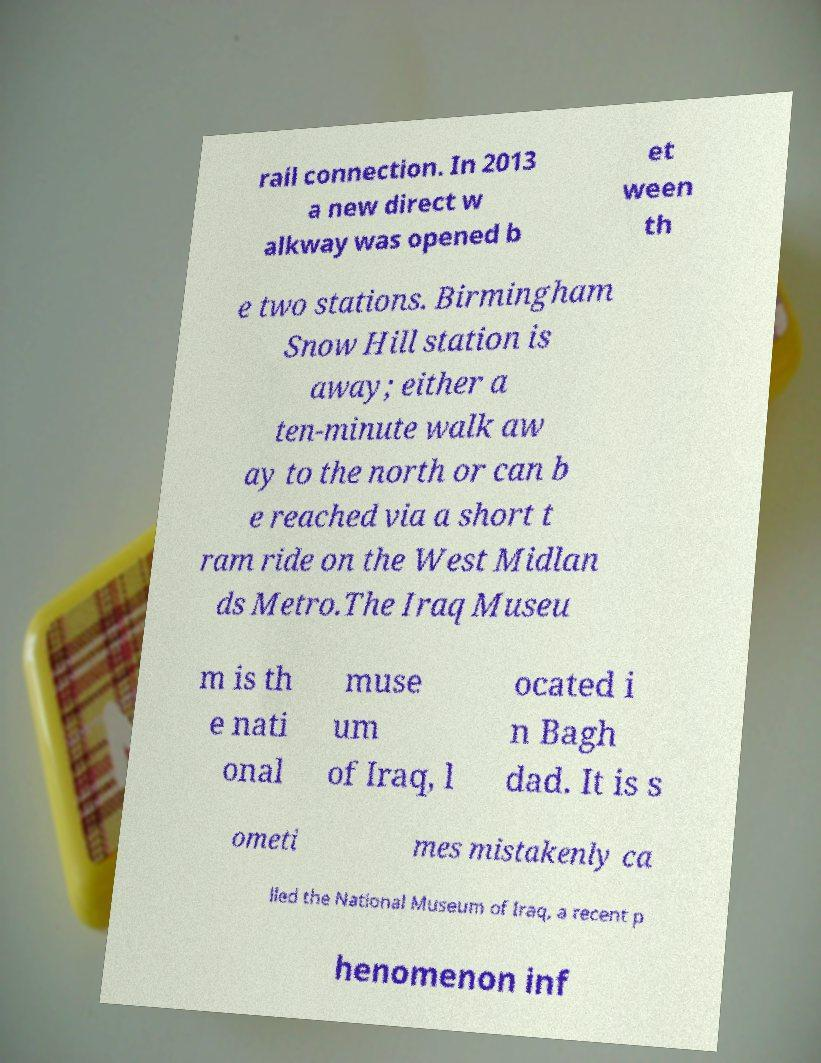Can you read and provide the text displayed in the image?This photo seems to have some interesting text. Can you extract and type it out for me? rail connection. In 2013 a new direct w alkway was opened b et ween th e two stations. Birmingham Snow Hill station is away; either a ten-minute walk aw ay to the north or can b e reached via a short t ram ride on the West Midlan ds Metro.The Iraq Museu m is th e nati onal muse um of Iraq, l ocated i n Bagh dad. It is s ometi mes mistakenly ca lled the National Museum of Iraq, a recent p henomenon inf 